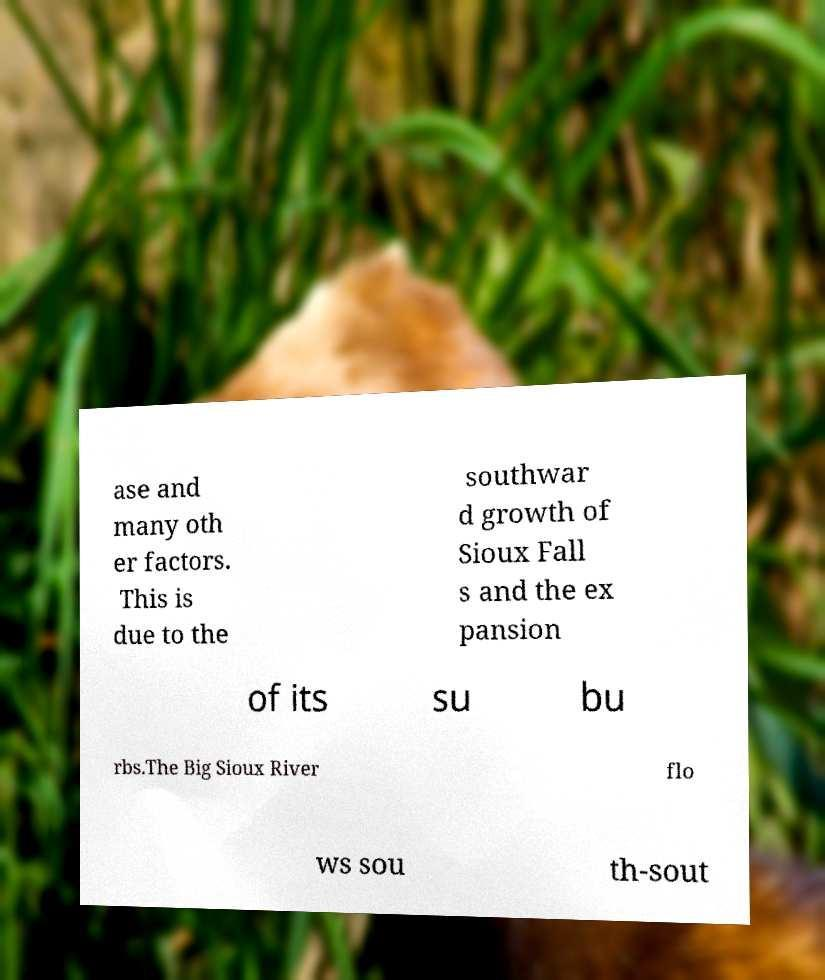Can you accurately transcribe the text from the provided image for me? ase and many oth er factors. This is due to the southwar d growth of Sioux Fall s and the ex pansion of its su bu rbs.The Big Sioux River flo ws sou th-sout 